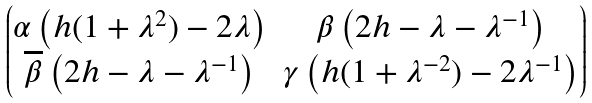Convert formula to latex. <formula><loc_0><loc_0><loc_500><loc_500>\begin{pmatrix} \alpha \left ( h ( 1 + \lambda ^ { 2 } ) - 2 \lambda \right ) & \beta \left ( 2 h - \lambda - \lambda ^ { - 1 } \right ) \\ \overline { \beta } \left ( 2 h - \lambda - \lambda ^ { - 1 } \right ) & \gamma \left ( h ( 1 + \lambda ^ { - 2 } ) - 2 \lambda ^ { - 1 } \right ) \end{pmatrix}</formula> 